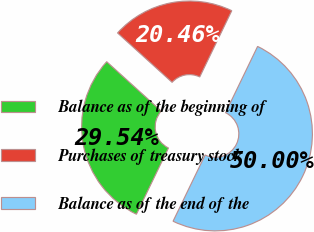Convert chart. <chart><loc_0><loc_0><loc_500><loc_500><pie_chart><fcel>Balance as of the beginning of<fcel>Purchases of treasury stock<fcel>Balance as of the end of the<nl><fcel>29.54%<fcel>20.46%<fcel>50.0%<nl></chart> 